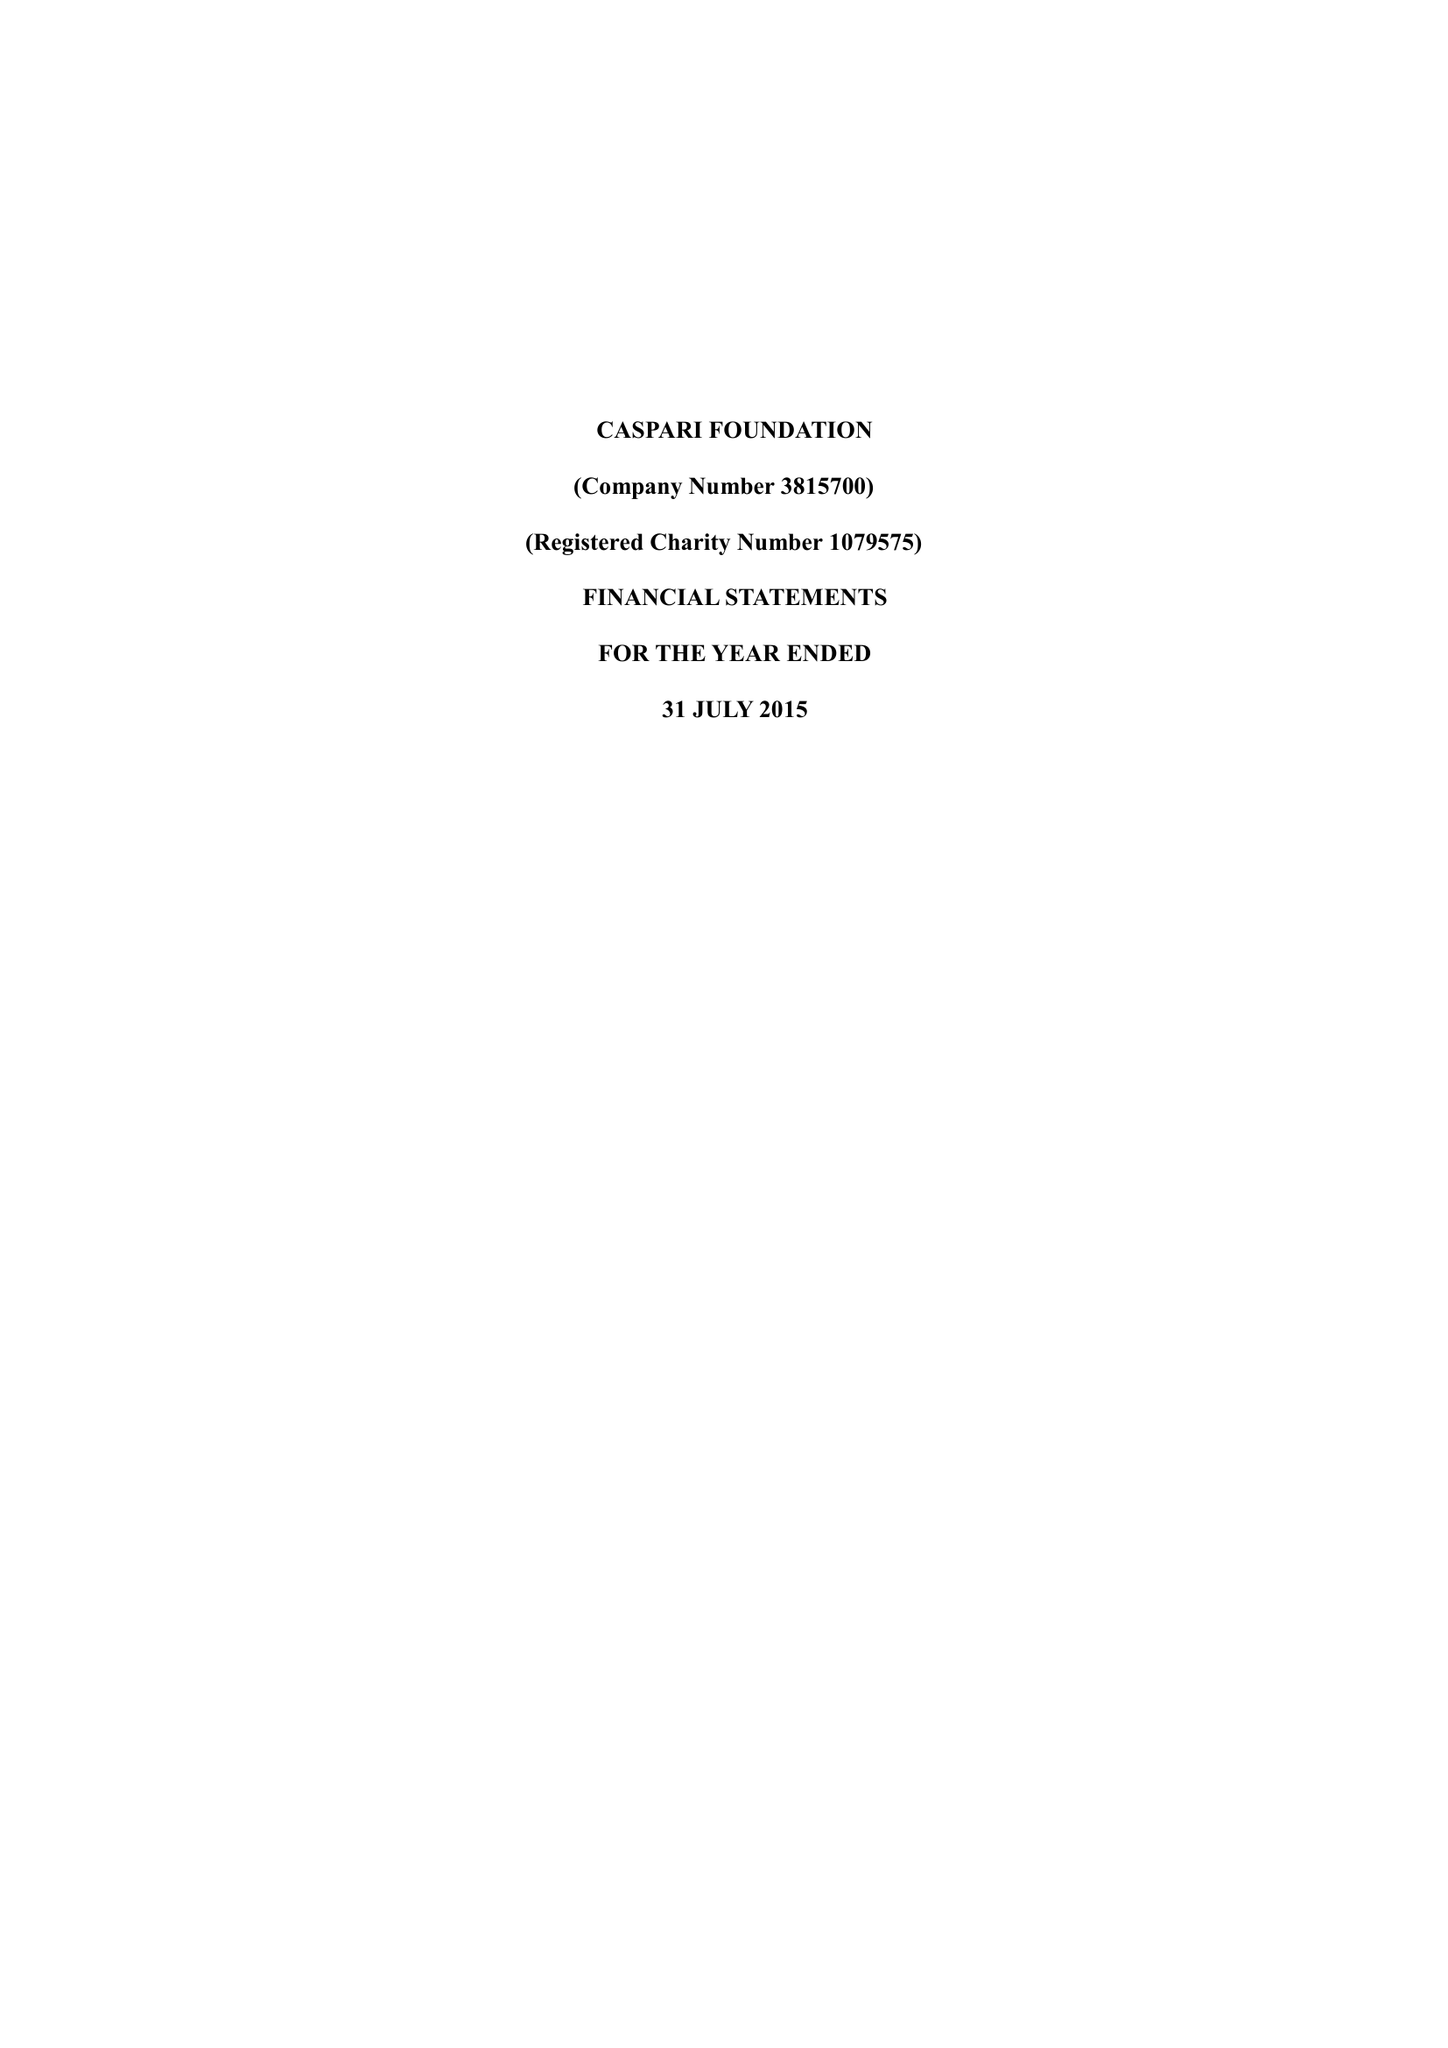What is the value for the address__postcode?
Answer the question using a single word or phrase. N4 2DA 